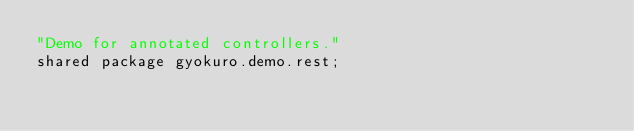<code> <loc_0><loc_0><loc_500><loc_500><_Ceylon_>"Demo for annotated controllers."
shared package gyokuro.demo.rest;
</code> 